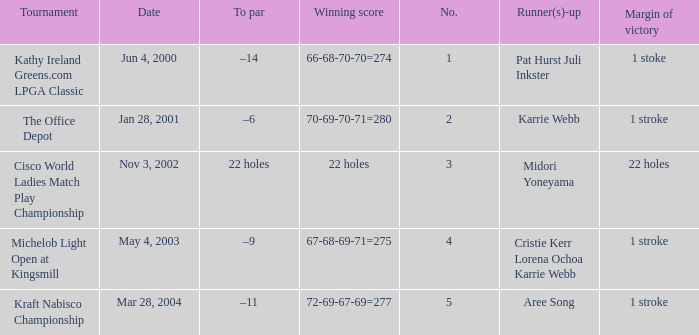What is the to par dated may 4, 2003? –9. 